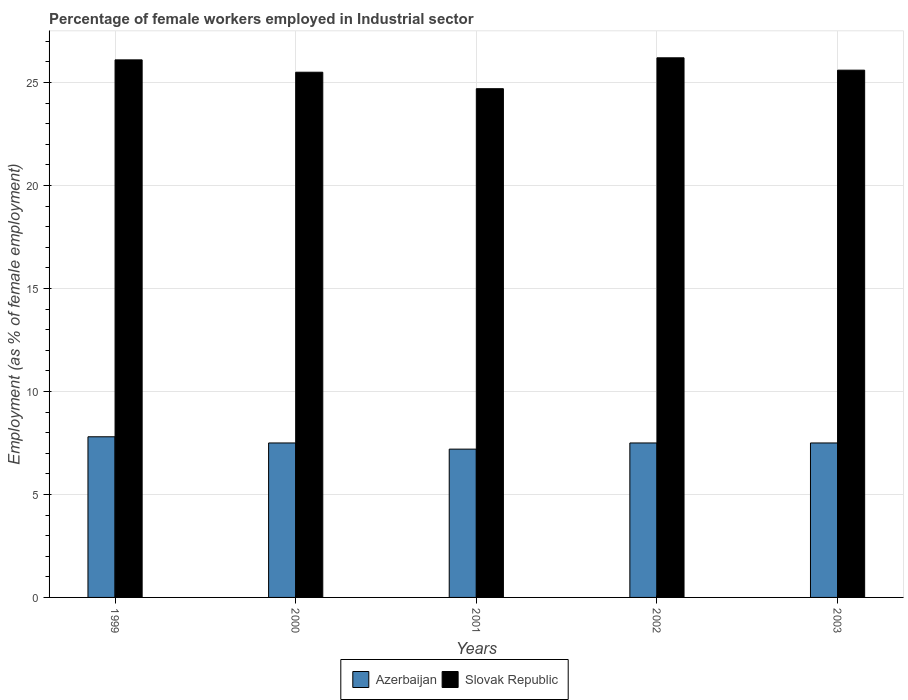How many bars are there on the 4th tick from the right?
Keep it short and to the point. 2. In how many cases, is the number of bars for a given year not equal to the number of legend labels?
Your answer should be compact. 0. What is the percentage of females employed in Industrial sector in Azerbaijan in 1999?
Offer a terse response. 7.8. Across all years, what is the maximum percentage of females employed in Industrial sector in Azerbaijan?
Offer a terse response. 7.8. Across all years, what is the minimum percentage of females employed in Industrial sector in Azerbaijan?
Your answer should be compact. 7.2. In which year was the percentage of females employed in Industrial sector in Slovak Republic maximum?
Make the answer very short. 2002. What is the total percentage of females employed in Industrial sector in Azerbaijan in the graph?
Your response must be concise. 37.5. What is the difference between the percentage of females employed in Industrial sector in Azerbaijan in 2001 and the percentage of females employed in Industrial sector in Slovak Republic in 2002?
Provide a short and direct response. -19. What is the average percentage of females employed in Industrial sector in Azerbaijan per year?
Your answer should be compact. 7.5. In the year 1999, what is the difference between the percentage of females employed in Industrial sector in Azerbaijan and percentage of females employed in Industrial sector in Slovak Republic?
Ensure brevity in your answer.  -18.3. What is the ratio of the percentage of females employed in Industrial sector in Slovak Republic in 2001 to that in 2002?
Make the answer very short. 0.94. Is the percentage of females employed in Industrial sector in Azerbaijan in 2000 less than that in 2001?
Ensure brevity in your answer.  No. Is the difference between the percentage of females employed in Industrial sector in Azerbaijan in 1999 and 2002 greater than the difference between the percentage of females employed in Industrial sector in Slovak Republic in 1999 and 2002?
Keep it short and to the point. Yes. What is the difference between the highest and the second highest percentage of females employed in Industrial sector in Slovak Republic?
Your answer should be compact. 0.1. What is the difference between the highest and the lowest percentage of females employed in Industrial sector in Azerbaijan?
Your answer should be very brief. 0.6. In how many years, is the percentage of females employed in Industrial sector in Azerbaijan greater than the average percentage of females employed in Industrial sector in Azerbaijan taken over all years?
Your answer should be compact. 1. What does the 1st bar from the left in 1999 represents?
Keep it short and to the point. Azerbaijan. What does the 1st bar from the right in 2001 represents?
Your response must be concise. Slovak Republic. Are all the bars in the graph horizontal?
Offer a terse response. No. How many years are there in the graph?
Make the answer very short. 5. Does the graph contain any zero values?
Offer a very short reply. No. Does the graph contain grids?
Your response must be concise. Yes. Where does the legend appear in the graph?
Offer a very short reply. Bottom center. How many legend labels are there?
Make the answer very short. 2. What is the title of the graph?
Give a very brief answer. Percentage of female workers employed in Industrial sector. Does "Upper middle income" appear as one of the legend labels in the graph?
Your answer should be very brief. No. What is the label or title of the X-axis?
Keep it short and to the point. Years. What is the label or title of the Y-axis?
Your answer should be compact. Employment (as % of female employment). What is the Employment (as % of female employment) in Azerbaijan in 1999?
Your answer should be compact. 7.8. What is the Employment (as % of female employment) in Slovak Republic in 1999?
Your answer should be very brief. 26.1. What is the Employment (as % of female employment) in Azerbaijan in 2001?
Your answer should be compact. 7.2. What is the Employment (as % of female employment) in Slovak Republic in 2001?
Offer a terse response. 24.7. What is the Employment (as % of female employment) of Slovak Republic in 2002?
Give a very brief answer. 26.2. What is the Employment (as % of female employment) in Slovak Republic in 2003?
Offer a very short reply. 25.6. Across all years, what is the maximum Employment (as % of female employment) of Azerbaijan?
Give a very brief answer. 7.8. Across all years, what is the maximum Employment (as % of female employment) in Slovak Republic?
Your response must be concise. 26.2. Across all years, what is the minimum Employment (as % of female employment) in Azerbaijan?
Give a very brief answer. 7.2. Across all years, what is the minimum Employment (as % of female employment) in Slovak Republic?
Make the answer very short. 24.7. What is the total Employment (as % of female employment) in Azerbaijan in the graph?
Offer a terse response. 37.5. What is the total Employment (as % of female employment) of Slovak Republic in the graph?
Make the answer very short. 128.1. What is the difference between the Employment (as % of female employment) of Slovak Republic in 1999 and that in 2000?
Offer a terse response. 0.6. What is the difference between the Employment (as % of female employment) in Slovak Republic in 1999 and that in 2001?
Keep it short and to the point. 1.4. What is the difference between the Employment (as % of female employment) of Slovak Republic in 2000 and that in 2001?
Provide a succinct answer. 0.8. What is the difference between the Employment (as % of female employment) of Azerbaijan in 2000 and that in 2002?
Your response must be concise. 0. What is the difference between the Employment (as % of female employment) in Azerbaijan in 2000 and that in 2003?
Your answer should be compact. 0. What is the difference between the Employment (as % of female employment) in Slovak Republic in 2001 and that in 2003?
Your answer should be compact. -0.9. What is the difference between the Employment (as % of female employment) in Azerbaijan in 2002 and that in 2003?
Give a very brief answer. 0. What is the difference between the Employment (as % of female employment) of Slovak Republic in 2002 and that in 2003?
Offer a very short reply. 0.6. What is the difference between the Employment (as % of female employment) in Azerbaijan in 1999 and the Employment (as % of female employment) in Slovak Republic in 2000?
Keep it short and to the point. -17.7. What is the difference between the Employment (as % of female employment) of Azerbaijan in 1999 and the Employment (as % of female employment) of Slovak Republic in 2001?
Ensure brevity in your answer.  -16.9. What is the difference between the Employment (as % of female employment) in Azerbaijan in 1999 and the Employment (as % of female employment) in Slovak Republic in 2002?
Your answer should be very brief. -18.4. What is the difference between the Employment (as % of female employment) of Azerbaijan in 1999 and the Employment (as % of female employment) of Slovak Republic in 2003?
Make the answer very short. -17.8. What is the difference between the Employment (as % of female employment) in Azerbaijan in 2000 and the Employment (as % of female employment) in Slovak Republic in 2001?
Give a very brief answer. -17.2. What is the difference between the Employment (as % of female employment) in Azerbaijan in 2000 and the Employment (as % of female employment) in Slovak Republic in 2002?
Give a very brief answer. -18.7. What is the difference between the Employment (as % of female employment) of Azerbaijan in 2000 and the Employment (as % of female employment) of Slovak Republic in 2003?
Provide a short and direct response. -18.1. What is the difference between the Employment (as % of female employment) in Azerbaijan in 2001 and the Employment (as % of female employment) in Slovak Republic in 2003?
Keep it short and to the point. -18.4. What is the difference between the Employment (as % of female employment) in Azerbaijan in 2002 and the Employment (as % of female employment) in Slovak Republic in 2003?
Offer a very short reply. -18.1. What is the average Employment (as % of female employment) in Slovak Republic per year?
Your answer should be compact. 25.62. In the year 1999, what is the difference between the Employment (as % of female employment) in Azerbaijan and Employment (as % of female employment) in Slovak Republic?
Provide a succinct answer. -18.3. In the year 2000, what is the difference between the Employment (as % of female employment) of Azerbaijan and Employment (as % of female employment) of Slovak Republic?
Keep it short and to the point. -18. In the year 2001, what is the difference between the Employment (as % of female employment) in Azerbaijan and Employment (as % of female employment) in Slovak Republic?
Offer a terse response. -17.5. In the year 2002, what is the difference between the Employment (as % of female employment) of Azerbaijan and Employment (as % of female employment) of Slovak Republic?
Ensure brevity in your answer.  -18.7. In the year 2003, what is the difference between the Employment (as % of female employment) of Azerbaijan and Employment (as % of female employment) of Slovak Republic?
Offer a terse response. -18.1. What is the ratio of the Employment (as % of female employment) in Slovak Republic in 1999 to that in 2000?
Provide a short and direct response. 1.02. What is the ratio of the Employment (as % of female employment) of Azerbaijan in 1999 to that in 2001?
Your answer should be very brief. 1.08. What is the ratio of the Employment (as % of female employment) in Slovak Republic in 1999 to that in 2001?
Your answer should be compact. 1.06. What is the ratio of the Employment (as % of female employment) in Azerbaijan in 1999 to that in 2002?
Your answer should be compact. 1.04. What is the ratio of the Employment (as % of female employment) in Slovak Republic in 1999 to that in 2002?
Offer a terse response. 1. What is the ratio of the Employment (as % of female employment) in Azerbaijan in 1999 to that in 2003?
Your answer should be compact. 1.04. What is the ratio of the Employment (as % of female employment) of Slovak Republic in 1999 to that in 2003?
Make the answer very short. 1.02. What is the ratio of the Employment (as % of female employment) of Azerbaijan in 2000 to that in 2001?
Give a very brief answer. 1.04. What is the ratio of the Employment (as % of female employment) of Slovak Republic in 2000 to that in 2001?
Offer a terse response. 1.03. What is the ratio of the Employment (as % of female employment) in Slovak Republic in 2000 to that in 2002?
Your answer should be compact. 0.97. What is the ratio of the Employment (as % of female employment) in Azerbaijan in 2000 to that in 2003?
Give a very brief answer. 1. What is the ratio of the Employment (as % of female employment) in Slovak Republic in 2000 to that in 2003?
Your answer should be very brief. 1. What is the ratio of the Employment (as % of female employment) in Azerbaijan in 2001 to that in 2002?
Keep it short and to the point. 0.96. What is the ratio of the Employment (as % of female employment) in Slovak Republic in 2001 to that in 2002?
Ensure brevity in your answer.  0.94. What is the ratio of the Employment (as % of female employment) of Azerbaijan in 2001 to that in 2003?
Provide a succinct answer. 0.96. What is the ratio of the Employment (as % of female employment) of Slovak Republic in 2001 to that in 2003?
Give a very brief answer. 0.96. What is the ratio of the Employment (as % of female employment) in Azerbaijan in 2002 to that in 2003?
Your answer should be very brief. 1. What is the ratio of the Employment (as % of female employment) of Slovak Republic in 2002 to that in 2003?
Keep it short and to the point. 1.02. What is the difference between the highest and the lowest Employment (as % of female employment) in Slovak Republic?
Your answer should be compact. 1.5. 